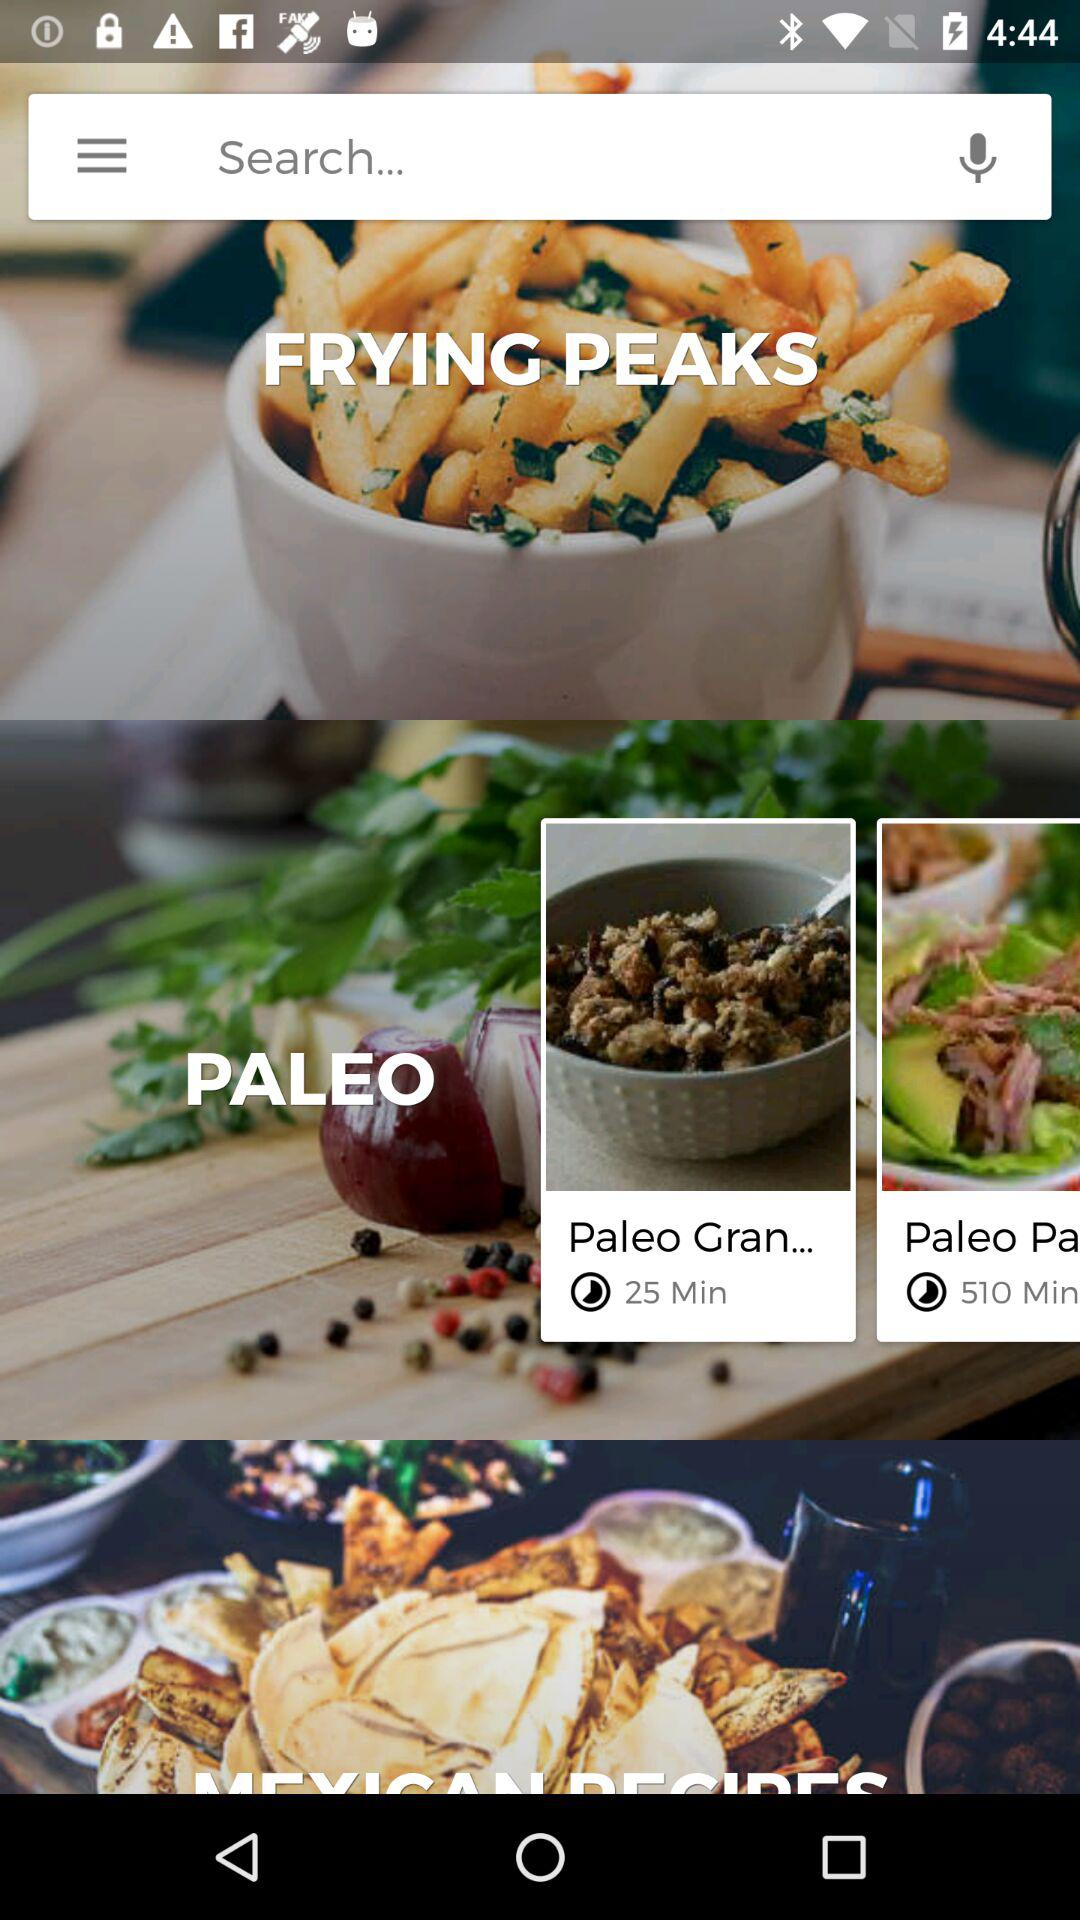How many items have a time element?
Answer the question using a single word or phrase. 2 